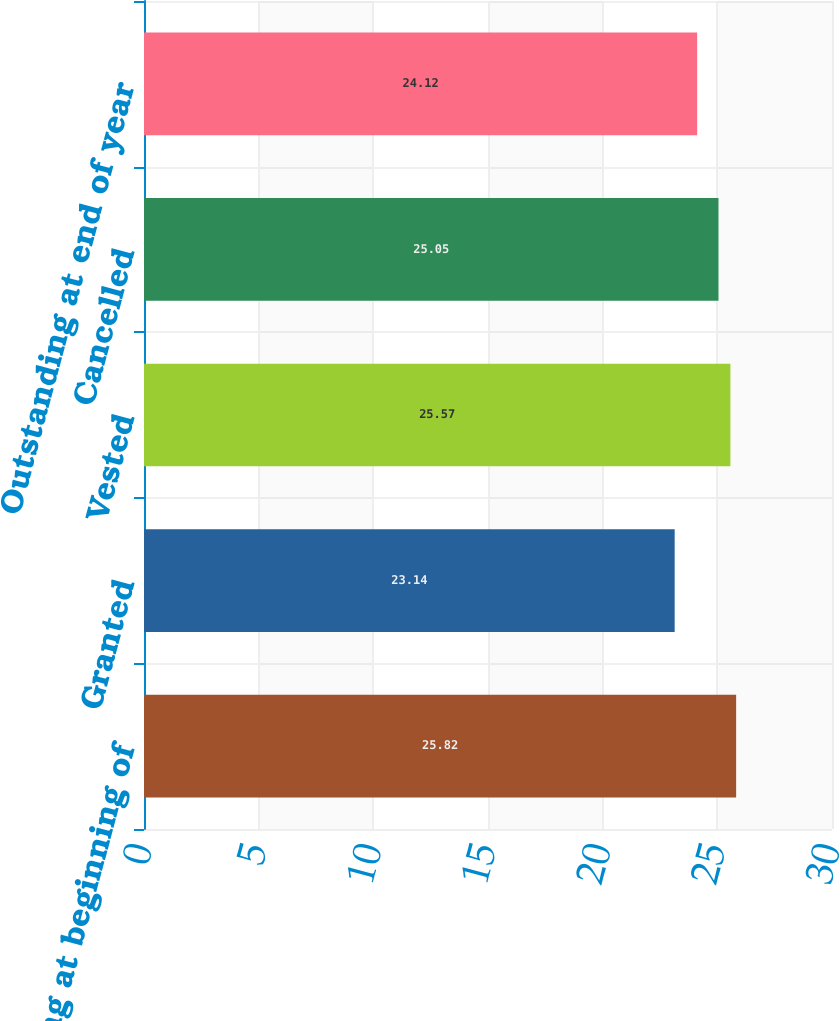Convert chart. <chart><loc_0><loc_0><loc_500><loc_500><bar_chart><fcel>Outstanding at beginning of<fcel>Granted<fcel>Vested<fcel>Cancelled<fcel>Outstanding at end of year<nl><fcel>25.82<fcel>23.14<fcel>25.57<fcel>25.05<fcel>24.12<nl></chart> 